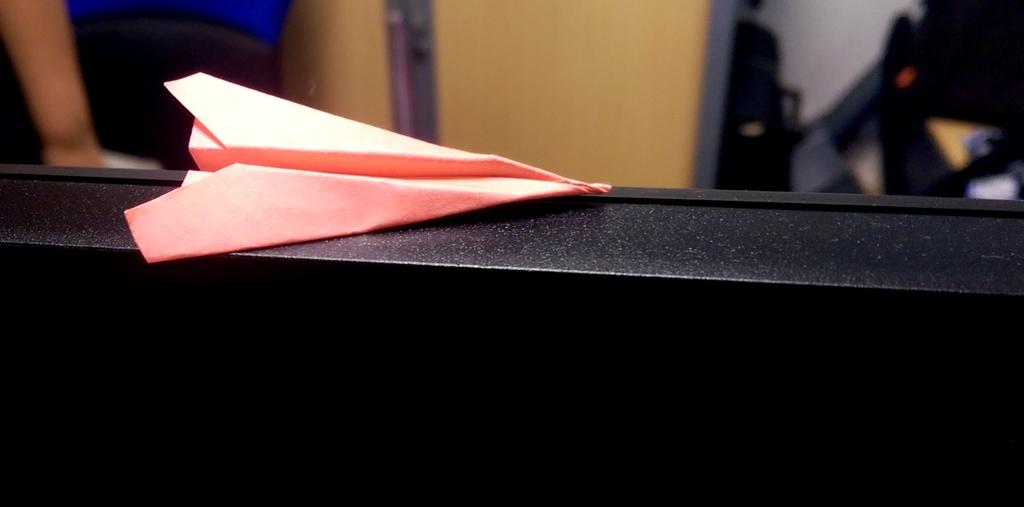What is the color of the paper plane in the image? The paper plane in the image is pink. What is the paper plane placed on? The paper plane is placed on a black color surface. How would you describe the background of the image? The background of the image is blurred. Can you see any objects in the blurred background? Yes, there are objects visible in the blurred background. What type of wish can be granted by the pail in the image? There is no pail present in the image, so it is not possible to grant any wishes with it. Is there a guitar visible in the image? No, there is no guitar present in the image. 